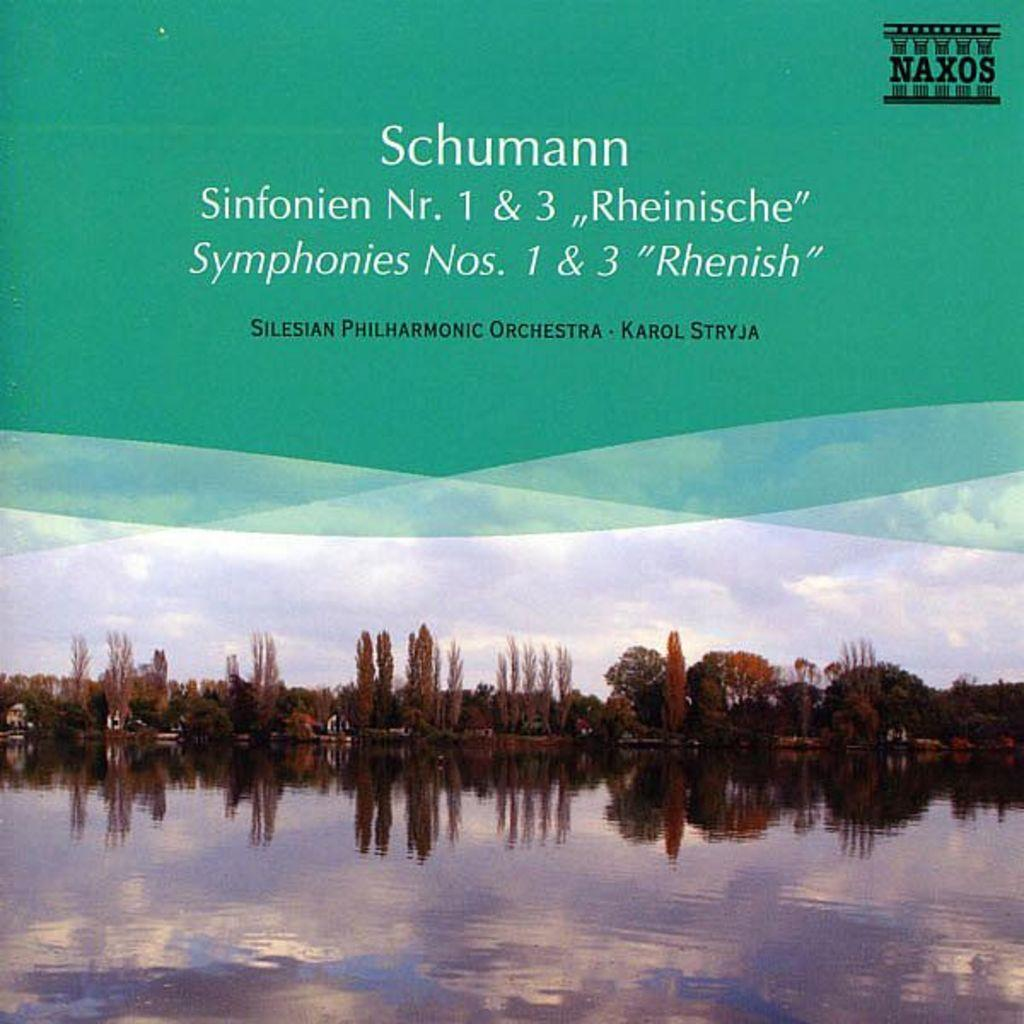What is present on the poster in the image? There is a poster in the image. What images can be seen on the poster? The poster contains an image of water and images of trees. Is there any text on the poster? Yes, there is text on the poster. What type of pest can be seen crawling on the poster in the image? There is no pest present on the poster in the image. What season is depicted in the image? The provided facts do not mention any season or time of year in the image. 